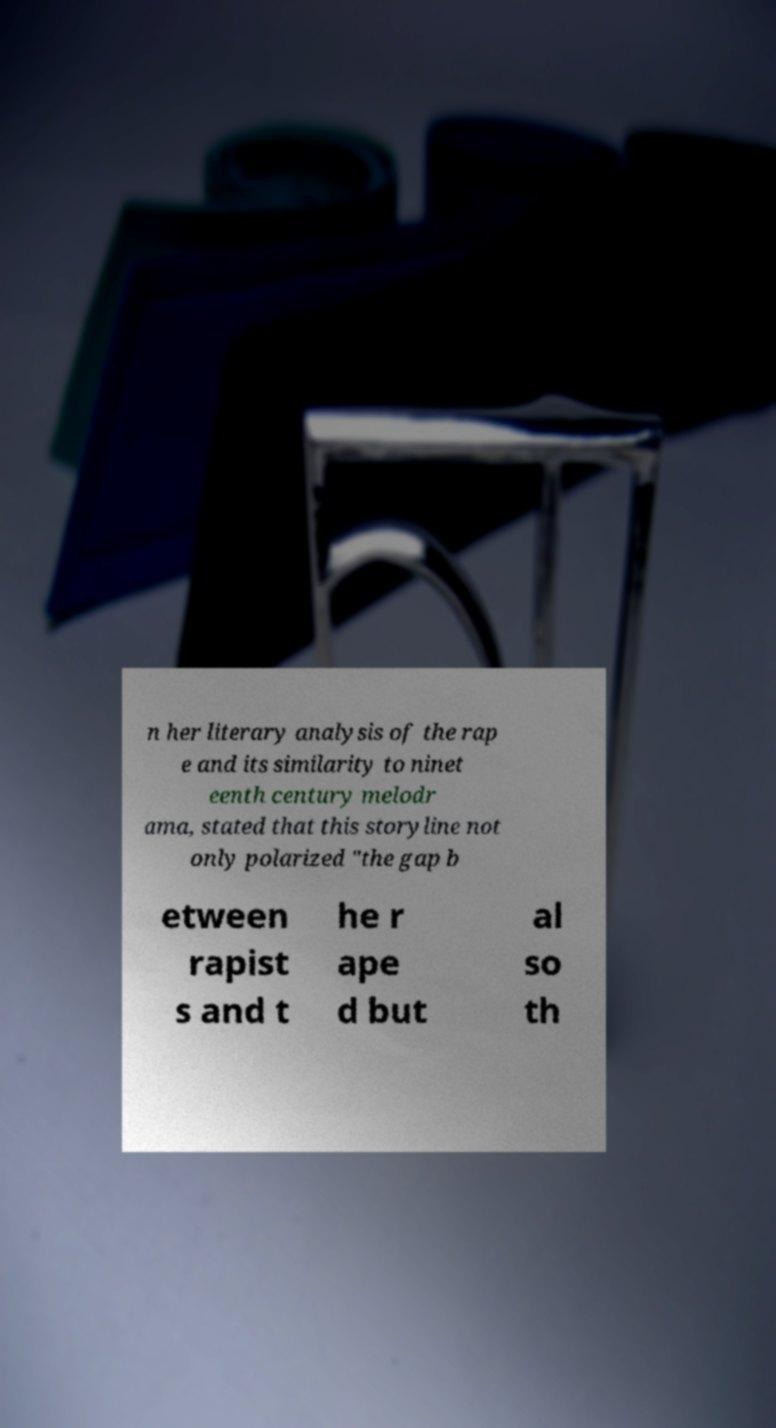Can you accurately transcribe the text from the provided image for me? n her literary analysis of the rap e and its similarity to ninet eenth century melodr ama, stated that this storyline not only polarized "the gap b etween rapist s and t he r ape d but al so th 